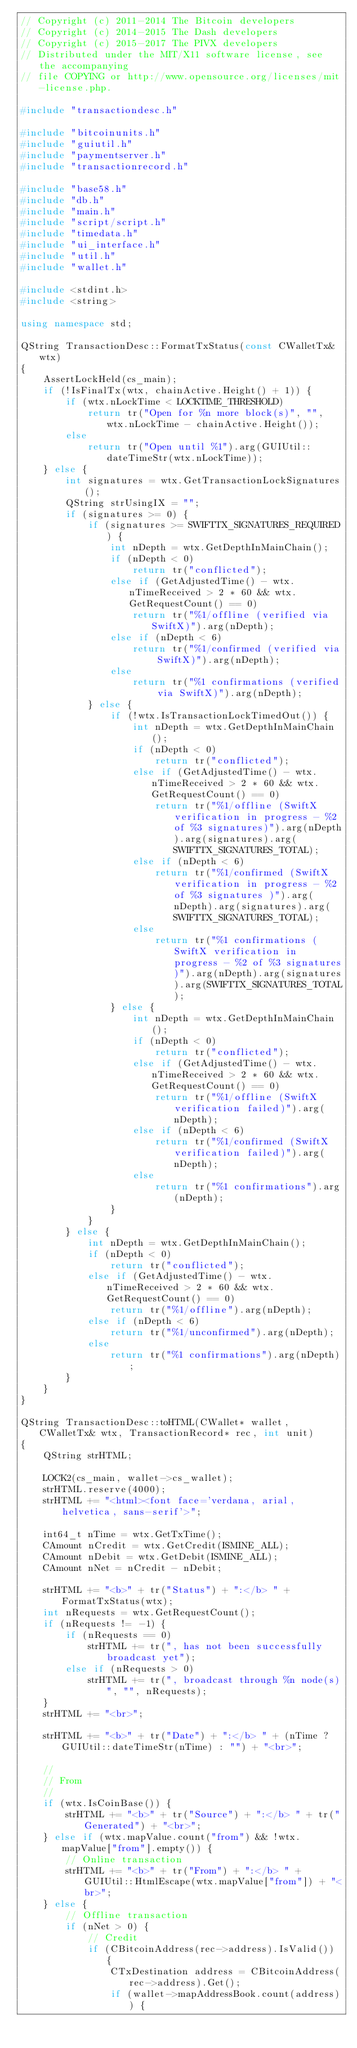Convert code to text. <code><loc_0><loc_0><loc_500><loc_500><_C++_>// Copyright (c) 2011-2014 The Bitcoin developers
// Copyright (c) 2014-2015 The Dash developers
// Copyright (c) 2015-2017 The PIVX developers
// Distributed under the MIT/X11 software license, see the accompanying
// file COPYING or http://www.opensource.org/licenses/mit-license.php.

#include "transactiondesc.h"

#include "bitcoinunits.h"
#include "guiutil.h"
#include "paymentserver.h"
#include "transactionrecord.h"

#include "base58.h"
#include "db.h"
#include "main.h"
#include "script/script.h"
#include "timedata.h"
#include "ui_interface.h"
#include "util.h"
#include "wallet.h"

#include <stdint.h>
#include <string>

using namespace std;

QString TransactionDesc::FormatTxStatus(const CWalletTx& wtx)
{
    AssertLockHeld(cs_main);
    if (!IsFinalTx(wtx, chainActive.Height() + 1)) {
        if (wtx.nLockTime < LOCKTIME_THRESHOLD)
            return tr("Open for %n more block(s)", "", wtx.nLockTime - chainActive.Height());
        else
            return tr("Open until %1").arg(GUIUtil::dateTimeStr(wtx.nLockTime));
    } else {
        int signatures = wtx.GetTransactionLockSignatures();
        QString strUsingIX = "";
        if (signatures >= 0) {
            if (signatures >= SWIFTTX_SIGNATURES_REQUIRED) {
                int nDepth = wtx.GetDepthInMainChain();
                if (nDepth < 0)
                    return tr("conflicted");
                else if (GetAdjustedTime() - wtx.nTimeReceived > 2 * 60 && wtx.GetRequestCount() == 0)
                    return tr("%1/offline (verified via SwiftX)").arg(nDepth);
                else if (nDepth < 6)
                    return tr("%1/confirmed (verified via SwiftX)").arg(nDepth);
                else
                    return tr("%1 confirmations (verified via SwiftX)").arg(nDepth);
            } else {
                if (!wtx.IsTransactionLockTimedOut()) {
                    int nDepth = wtx.GetDepthInMainChain();
                    if (nDepth < 0)
                        return tr("conflicted");
                    else if (GetAdjustedTime() - wtx.nTimeReceived > 2 * 60 && wtx.GetRequestCount() == 0)
                        return tr("%1/offline (SwiftX verification in progress - %2 of %3 signatures)").arg(nDepth).arg(signatures).arg(SWIFTTX_SIGNATURES_TOTAL);
                    else if (nDepth < 6)
                        return tr("%1/confirmed (SwiftX verification in progress - %2 of %3 signatures )").arg(nDepth).arg(signatures).arg(SWIFTTX_SIGNATURES_TOTAL);
                    else
                        return tr("%1 confirmations (SwiftX verification in progress - %2 of %3 signatures)").arg(nDepth).arg(signatures).arg(SWIFTTX_SIGNATURES_TOTAL);
                } else {
                    int nDepth = wtx.GetDepthInMainChain();
                    if (nDepth < 0)
                        return tr("conflicted");
                    else if (GetAdjustedTime() - wtx.nTimeReceived > 2 * 60 && wtx.GetRequestCount() == 0)
                        return tr("%1/offline (SwiftX verification failed)").arg(nDepth);
                    else if (nDepth < 6)
                        return tr("%1/confirmed (SwiftX verification failed)").arg(nDepth);
                    else
                        return tr("%1 confirmations").arg(nDepth);
                }
            }
        } else {
            int nDepth = wtx.GetDepthInMainChain();
            if (nDepth < 0)
                return tr("conflicted");
            else if (GetAdjustedTime() - wtx.nTimeReceived > 2 * 60 && wtx.GetRequestCount() == 0)
                return tr("%1/offline").arg(nDepth);
            else if (nDepth < 6)
                return tr("%1/unconfirmed").arg(nDepth);
            else
                return tr("%1 confirmations").arg(nDepth);
        }
    }
}

QString TransactionDesc::toHTML(CWallet* wallet, CWalletTx& wtx, TransactionRecord* rec, int unit)
{
    QString strHTML;

    LOCK2(cs_main, wallet->cs_wallet);
    strHTML.reserve(4000);
    strHTML += "<html><font face='verdana, arial, helvetica, sans-serif'>";

    int64_t nTime = wtx.GetTxTime();
    CAmount nCredit = wtx.GetCredit(ISMINE_ALL);
    CAmount nDebit = wtx.GetDebit(ISMINE_ALL);
    CAmount nNet = nCredit - nDebit;

    strHTML += "<b>" + tr("Status") + ":</b> " + FormatTxStatus(wtx);
    int nRequests = wtx.GetRequestCount();
    if (nRequests != -1) {
        if (nRequests == 0)
            strHTML += tr(", has not been successfully broadcast yet");
        else if (nRequests > 0)
            strHTML += tr(", broadcast through %n node(s)", "", nRequests);
    }
    strHTML += "<br>";

    strHTML += "<b>" + tr("Date") + ":</b> " + (nTime ? GUIUtil::dateTimeStr(nTime) : "") + "<br>";

    //
    // From
    //
    if (wtx.IsCoinBase()) {
        strHTML += "<b>" + tr("Source") + ":</b> " + tr("Generated") + "<br>";
    } else if (wtx.mapValue.count("from") && !wtx.mapValue["from"].empty()) {
        // Online transaction
        strHTML += "<b>" + tr("From") + ":</b> " + GUIUtil::HtmlEscape(wtx.mapValue["from"]) + "<br>";
    } else {
        // Offline transaction
        if (nNet > 0) {
            // Credit
            if (CBitcoinAddress(rec->address).IsValid()) {
                CTxDestination address = CBitcoinAddress(rec->address).Get();
                if (wallet->mapAddressBook.count(address)) {</code> 